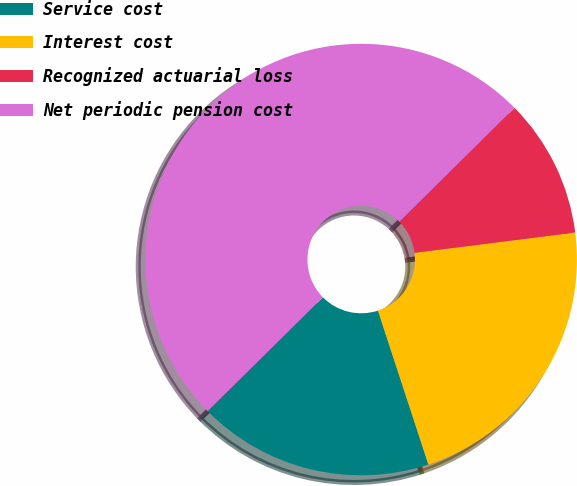Convert chart. <chart><loc_0><loc_0><loc_500><loc_500><pie_chart><fcel>Service cost<fcel>Interest cost<fcel>Recognized actuarial loss<fcel>Net periodic pension cost<nl><fcel>17.64%<fcel>21.96%<fcel>10.41%<fcel>50.0%<nl></chart> 